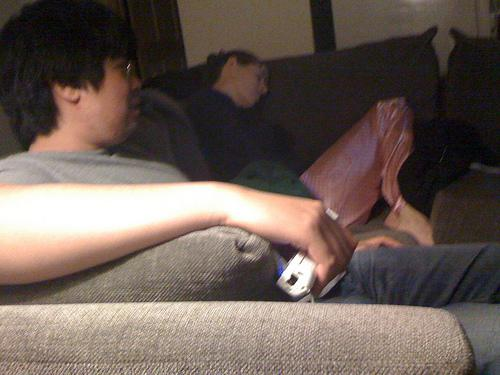Question: where was the picture taken?
Choices:
A. On a farm.
B. In a living room.
C. At a skate park.
D. At the zoo.
Answer with the letter. Answer: B Question: what color is the sofa?
Choices:
A. Gray.
B. Brown.
C. Black.
D. Blue.
Answer with the letter. Answer: A Question: who is wearing glasses?
Choices:
A. The man.
B. The woman.
C. The boy.
D. The girl.
Answer with the letter. Answer: A Question: what are the people sitting on?
Choices:
A. The sofa.
B. The bench.
C. The chair.
D. The bed.
Answer with the letter. Answer: A 